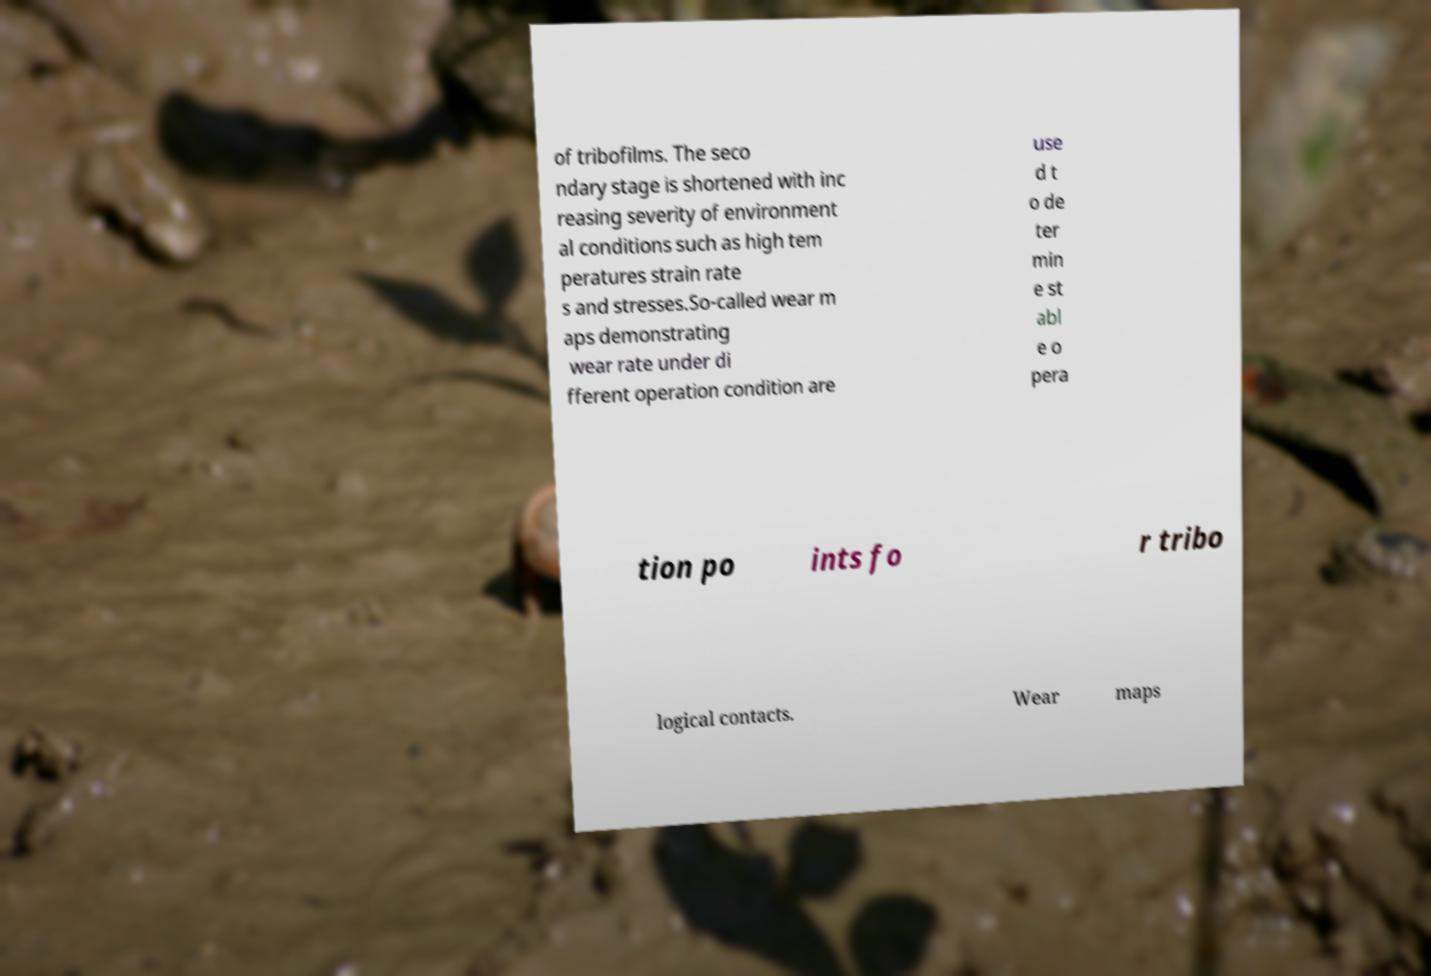Please identify and transcribe the text found in this image. of tribofilms. The seco ndary stage is shortened with inc reasing severity of environment al conditions such as high tem peratures strain rate s and stresses.So-called wear m aps demonstrating wear rate under di fferent operation condition are use d t o de ter min e st abl e o pera tion po ints fo r tribo logical contacts. Wear maps 